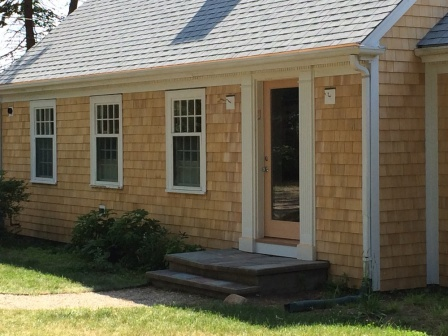Can you describe the main features of this image for me? The image depicts a charming residential scene featuring a well-maintained house. The house is adorned with warm, natural wood siding and has a gray shingle roof, which complements the overall aesthetic. White trim borders the windows and doors, enhancing the clean and inviting appearance of the home.

The front of the house showcases three windows with white frames and grids, creating a sense of symmetry and adding an elegant touch to the facade. A wooden door with glass panels stands slightly ajar, inviting curiosity about the home's interior. The door is accessible via a small set of wooden steps, surrounded by neatly trimmed bushes, indicating a well-cared-for exterior.

A stone walkway winds through the lush green lawn, leading up to the front steps, inviting visitors to the entrance. A blue hose is coiled on the right side of the house, suggesting that there is a garden or yard area out of view, where this hose might be used for watering plants or other outdoor activities.

Overall, the image captures a serene and welcoming residential scene that exudes a sense of orderliness and care. 